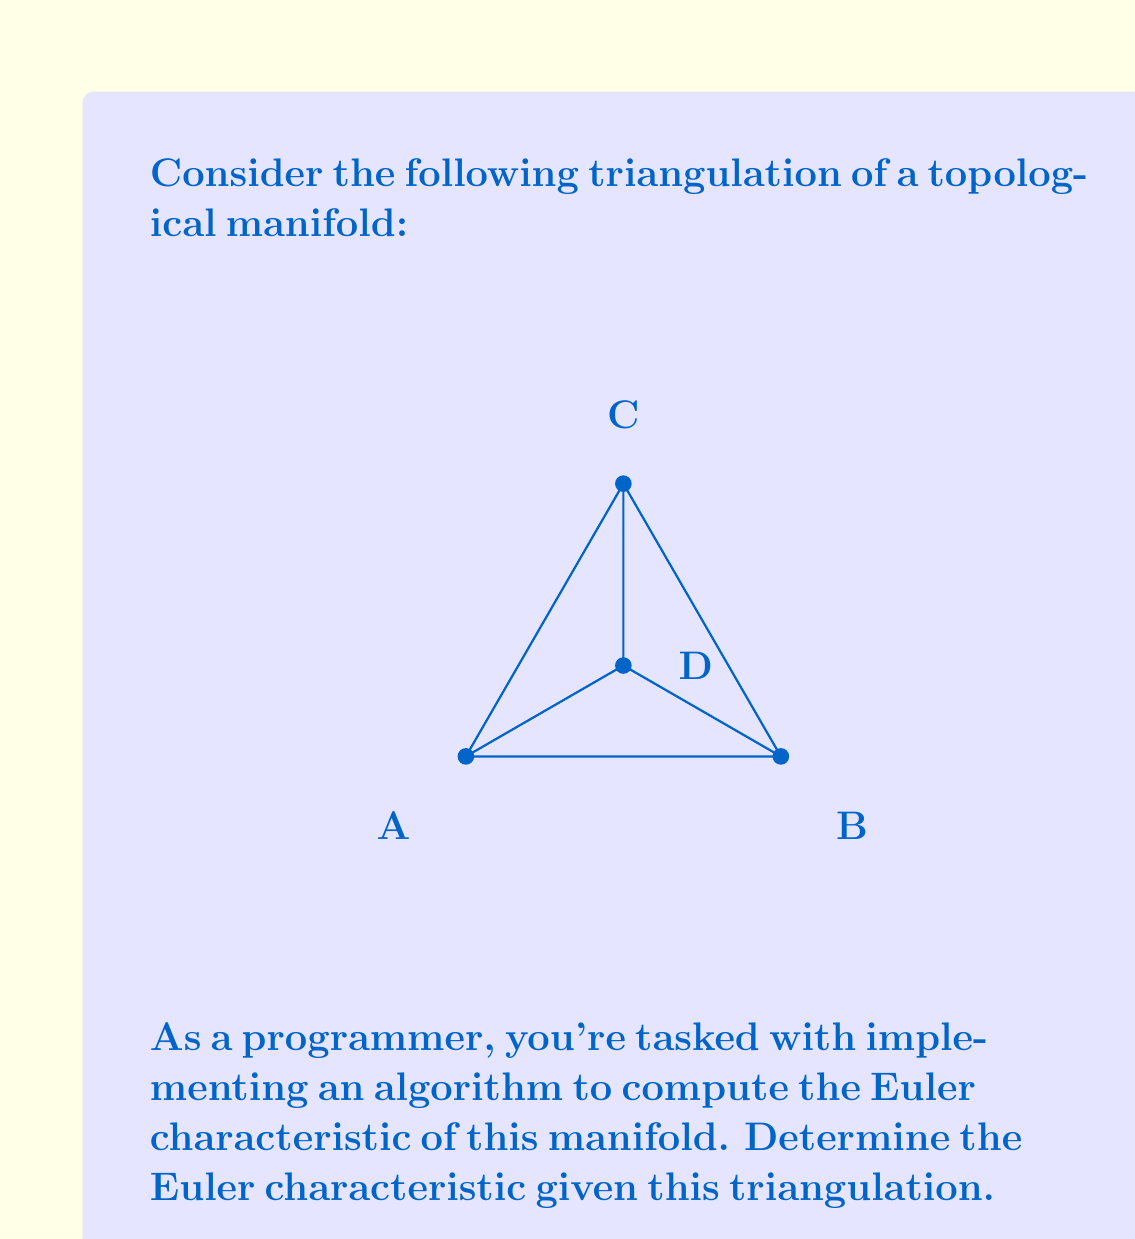Teach me how to tackle this problem. To calculate the Euler characteristic of a topological manifold given its triangulation, we use the formula:

$$\chi = V - E + F$$

Where:
$\chi$ is the Euler characteristic
$V$ is the number of vertices
$E$ is the number of edges
$F$ is the number of faces

Let's count each element:

1. Vertices (V):
   We can see 4 vertices in the triangulation: A, B, C, and D.
   Therefore, $V = 4$

2. Edges (E):
   We count 5 edges: AB, BC, CA, AD, BD, CD
   Therefore, $E = 5$

3. Faces (F):
   We can see 3 triangular faces: ABC, ACD, BCD
   Therefore, $F = 3$

Now, let's apply the formula:

$$\chi = V - E + F$$
$$\chi = 4 - 5 + 3$$
$$\chi = 2$$

The Euler characteristic of this manifold is 2, which suggests that it's topologically equivalent to a sphere.
Answer: $\chi = 2$ 